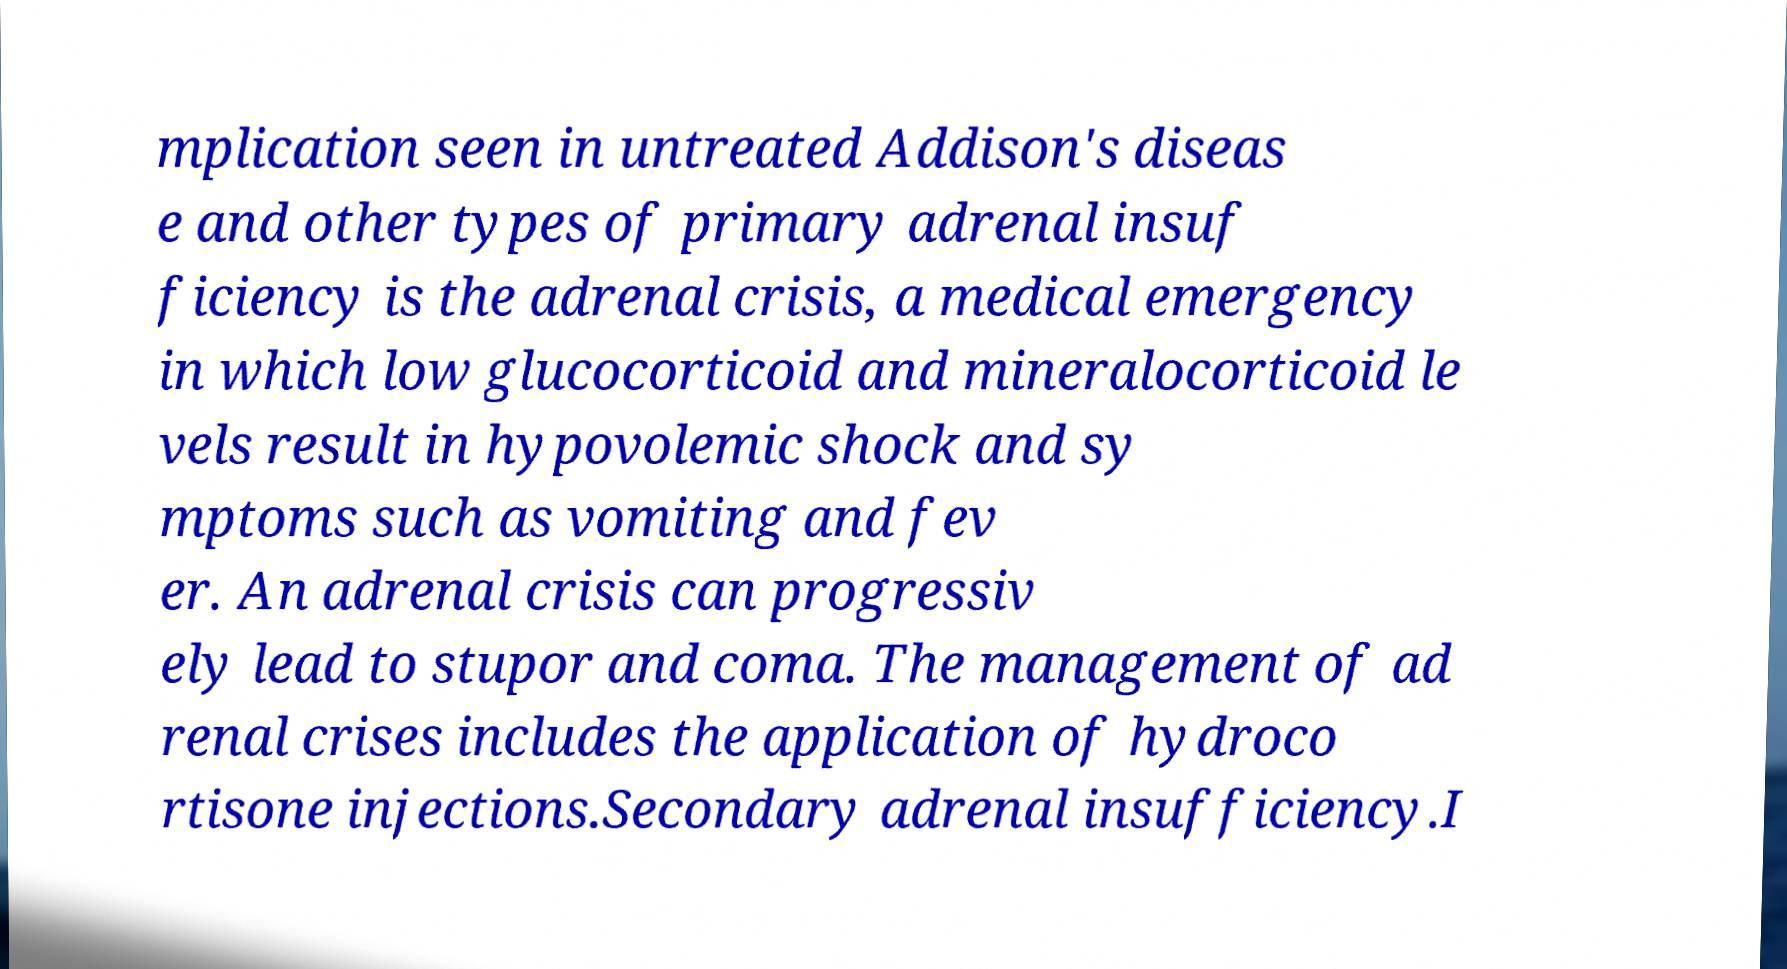Please identify and transcribe the text found in this image. mplication seen in untreated Addison's diseas e and other types of primary adrenal insuf ficiency is the adrenal crisis, a medical emergency in which low glucocorticoid and mineralocorticoid le vels result in hypovolemic shock and sy mptoms such as vomiting and fev er. An adrenal crisis can progressiv ely lead to stupor and coma. The management of ad renal crises includes the application of hydroco rtisone injections.Secondary adrenal insufficiency.I 